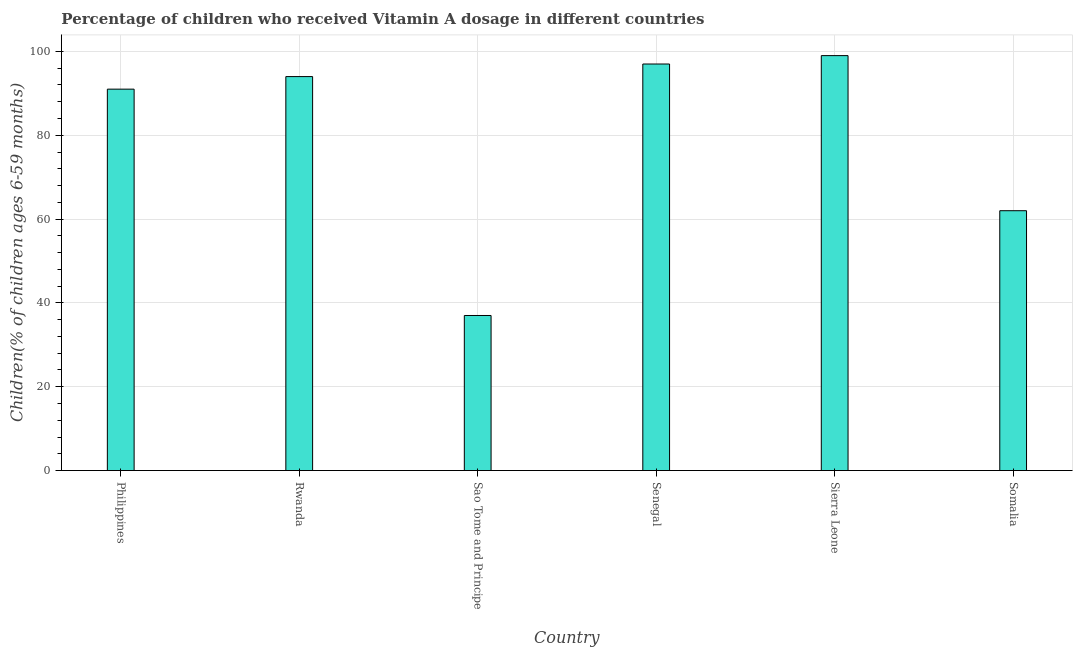Does the graph contain any zero values?
Make the answer very short. No. Does the graph contain grids?
Your answer should be compact. Yes. What is the title of the graph?
Your answer should be compact. Percentage of children who received Vitamin A dosage in different countries. What is the label or title of the X-axis?
Your response must be concise. Country. What is the label or title of the Y-axis?
Offer a terse response. Children(% of children ages 6-59 months). What is the vitamin a supplementation coverage rate in Senegal?
Ensure brevity in your answer.  97. Across all countries, what is the maximum vitamin a supplementation coverage rate?
Give a very brief answer. 99. In which country was the vitamin a supplementation coverage rate maximum?
Keep it short and to the point. Sierra Leone. In which country was the vitamin a supplementation coverage rate minimum?
Your answer should be very brief. Sao Tome and Principe. What is the sum of the vitamin a supplementation coverage rate?
Provide a short and direct response. 480. What is the difference between the vitamin a supplementation coverage rate in Rwanda and Somalia?
Offer a terse response. 32. What is the median vitamin a supplementation coverage rate?
Ensure brevity in your answer.  92.5. What is the ratio of the vitamin a supplementation coverage rate in Philippines to that in Sao Tome and Principe?
Your response must be concise. 2.46. Is the vitamin a supplementation coverage rate in Sao Tome and Principe less than that in Sierra Leone?
Make the answer very short. Yes. Is the difference between the vitamin a supplementation coverage rate in Rwanda and Sierra Leone greater than the difference between any two countries?
Keep it short and to the point. No. Is the sum of the vitamin a supplementation coverage rate in Rwanda and Sierra Leone greater than the maximum vitamin a supplementation coverage rate across all countries?
Keep it short and to the point. Yes. In how many countries, is the vitamin a supplementation coverage rate greater than the average vitamin a supplementation coverage rate taken over all countries?
Your answer should be very brief. 4. What is the Children(% of children ages 6-59 months) of Philippines?
Your answer should be very brief. 91. What is the Children(% of children ages 6-59 months) in Rwanda?
Give a very brief answer. 94. What is the Children(% of children ages 6-59 months) of Senegal?
Make the answer very short. 97. What is the Children(% of children ages 6-59 months) of Sierra Leone?
Keep it short and to the point. 99. What is the difference between the Children(% of children ages 6-59 months) in Philippines and Rwanda?
Provide a succinct answer. -3. What is the difference between the Children(% of children ages 6-59 months) in Philippines and Sao Tome and Principe?
Provide a succinct answer. 54. What is the difference between the Children(% of children ages 6-59 months) in Rwanda and Senegal?
Your answer should be compact. -3. What is the difference between the Children(% of children ages 6-59 months) in Sao Tome and Principe and Senegal?
Offer a terse response. -60. What is the difference between the Children(% of children ages 6-59 months) in Sao Tome and Principe and Sierra Leone?
Offer a very short reply. -62. What is the difference between the Children(% of children ages 6-59 months) in Sao Tome and Principe and Somalia?
Provide a short and direct response. -25. What is the difference between the Children(% of children ages 6-59 months) in Senegal and Sierra Leone?
Make the answer very short. -2. What is the ratio of the Children(% of children ages 6-59 months) in Philippines to that in Sao Tome and Principe?
Your response must be concise. 2.46. What is the ratio of the Children(% of children ages 6-59 months) in Philippines to that in Senegal?
Ensure brevity in your answer.  0.94. What is the ratio of the Children(% of children ages 6-59 months) in Philippines to that in Sierra Leone?
Ensure brevity in your answer.  0.92. What is the ratio of the Children(% of children ages 6-59 months) in Philippines to that in Somalia?
Give a very brief answer. 1.47. What is the ratio of the Children(% of children ages 6-59 months) in Rwanda to that in Sao Tome and Principe?
Your answer should be compact. 2.54. What is the ratio of the Children(% of children ages 6-59 months) in Rwanda to that in Sierra Leone?
Give a very brief answer. 0.95. What is the ratio of the Children(% of children ages 6-59 months) in Rwanda to that in Somalia?
Keep it short and to the point. 1.52. What is the ratio of the Children(% of children ages 6-59 months) in Sao Tome and Principe to that in Senegal?
Ensure brevity in your answer.  0.38. What is the ratio of the Children(% of children ages 6-59 months) in Sao Tome and Principe to that in Sierra Leone?
Your answer should be very brief. 0.37. What is the ratio of the Children(% of children ages 6-59 months) in Sao Tome and Principe to that in Somalia?
Your answer should be very brief. 0.6. What is the ratio of the Children(% of children ages 6-59 months) in Senegal to that in Somalia?
Keep it short and to the point. 1.56. What is the ratio of the Children(% of children ages 6-59 months) in Sierra Leone to that in Somalia?
Offer a very short reply. 1.6. 